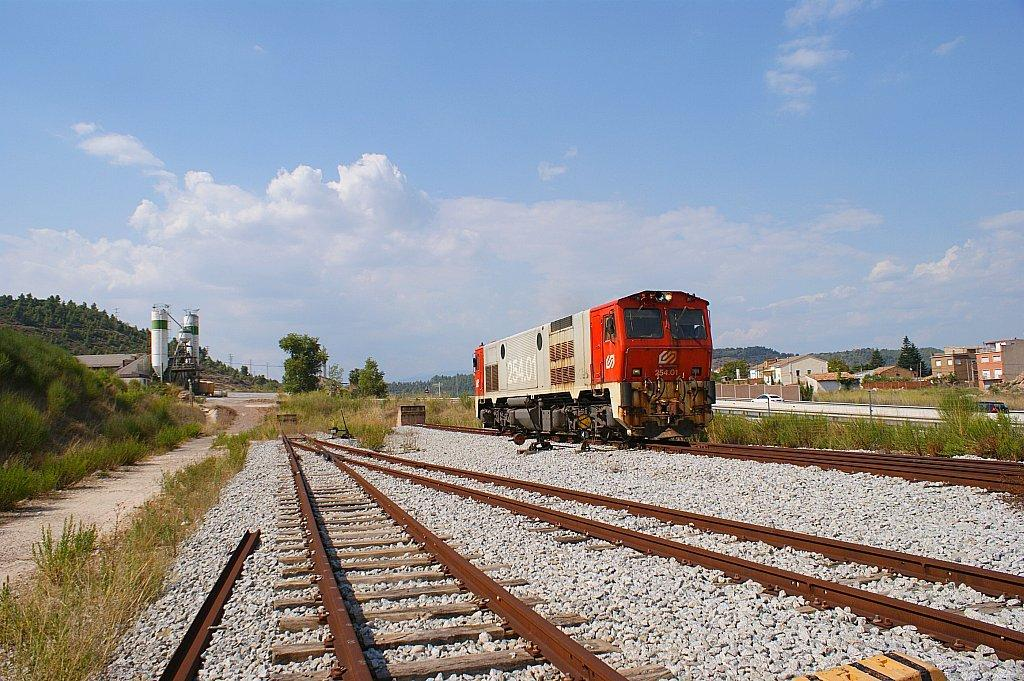What is the main subject of the image? The main subject of the image is a train. What is the train doing in the image? The train is moving on a railway track. What type of terrain can be seen in the image? There are stones, grass, and trees visible in the image. What type of structures are present in the image? There are wooden houses in the image. What is visible in the sky in the image? The sky is visible in the image, and clouds are present in the image. How many laborers are working on the iron clover in the image? There is no laborer or iron clover present in the image. 